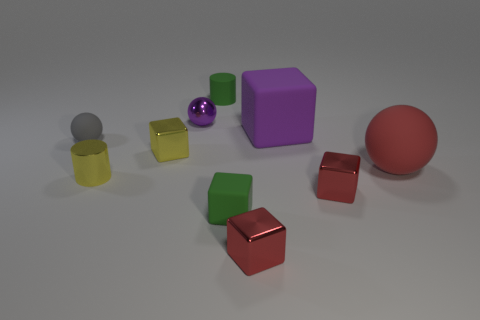Subtract all balls. How many objects are left? 7 Subtract all small purple blocks. Subtract all tiny gray balls. How many objects are left? 9 Add 1 purple rubber blocks. How many purple rubber blocks are left? 2 Add 10 large brown objects. How many large brown objects exist? 10 Subtract 0 yellow spheres. How many objects are left? 10 